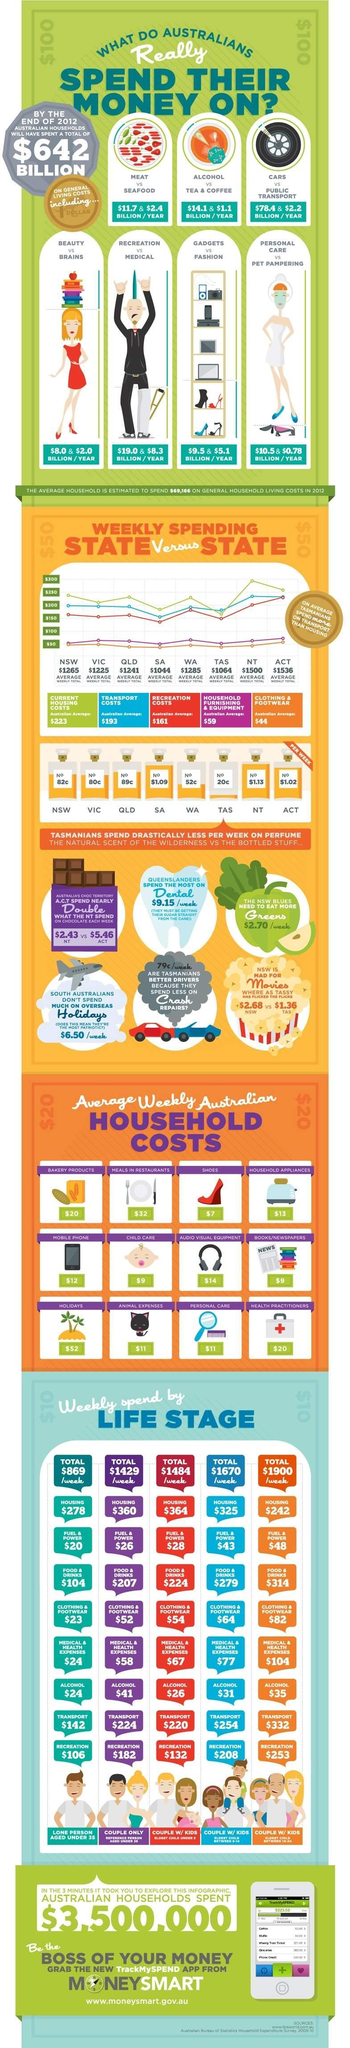How many billion per year is spent by the Australians on personal care?
Answer the question with a short phrase. $10.5 What is the average recreation costs of Australians? $161 How many billion per year is spent by the Australians on gadgets? $9.5 How many billion per year is spent by the Australians on Alcohol? $14.1 What is the average transport costs of Australians? $193 How many billion per year is spent by the Australians on public transport? $2.2 